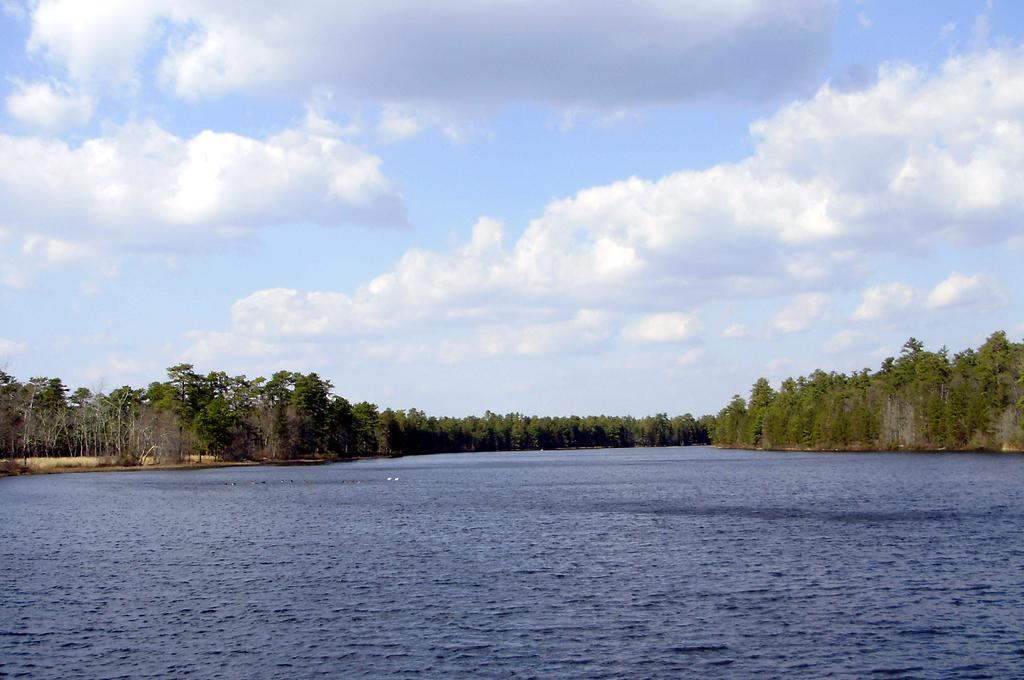What type of natural feature is present in the image? There is a river with water in the image. What other natural elements can be seen in the image? There are trees in the image. What is visible in the background of the image? The sky is visible in the image. What can be observed in the sky? There are clouds in the sky. What type of verse can be heard recited by the river in the image? There is no verse being recited in the image; it is a visual representation of a river with water, trees, and clouds in the sky. 